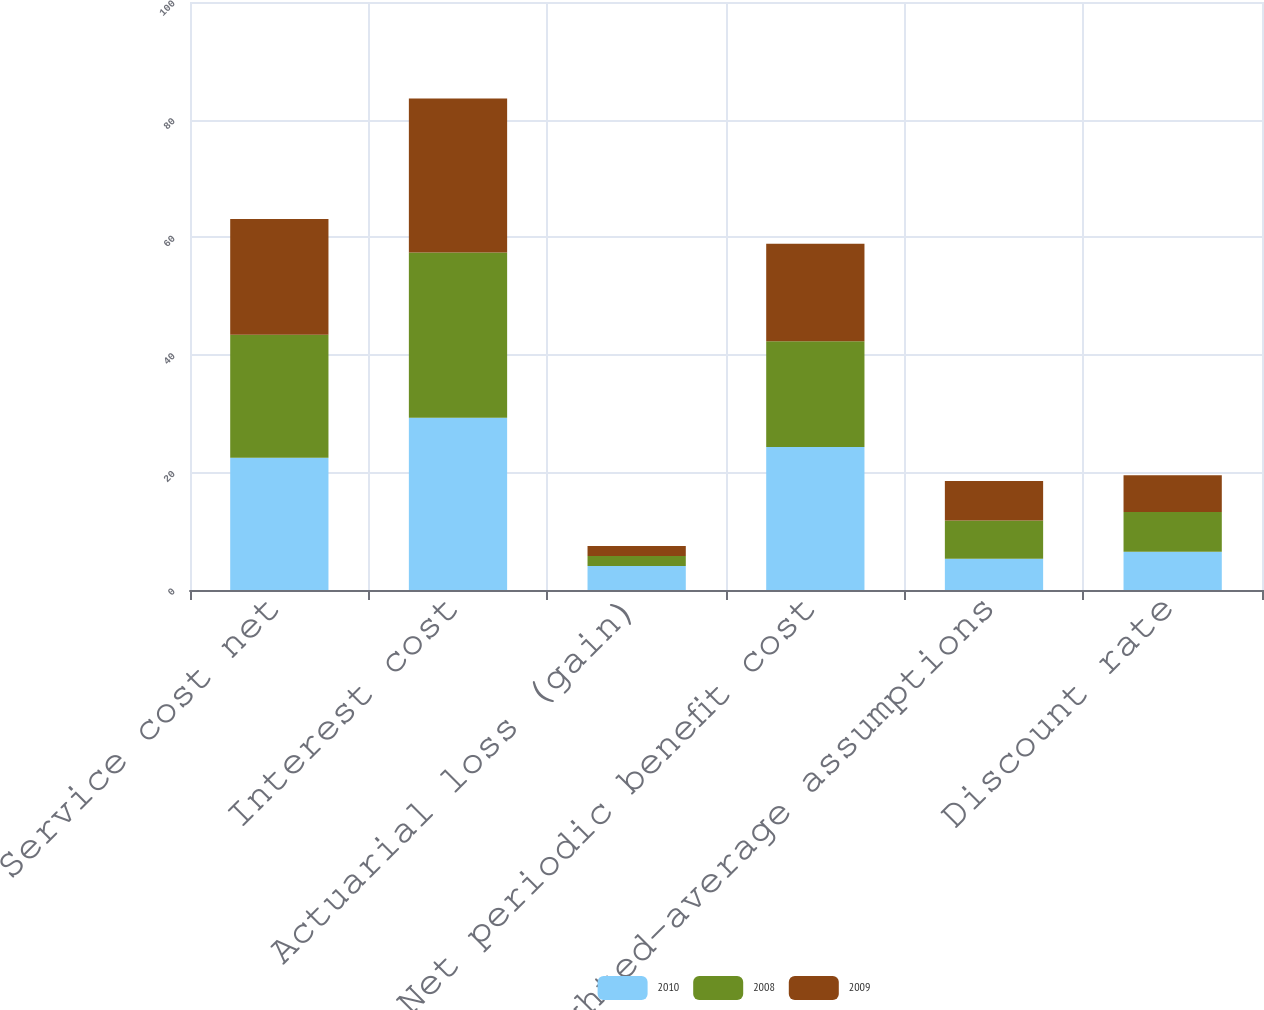<chart> <loc_0><loc_0><loc_500><loc_500><stacked_bar_chart><ecel><fcel>Service cost net<fcel>Interest cost<fcel>Actuarial loss (gain)<fcel>Net periodic benefit cost<fcel>Weighted-average assumptions<fcel>Discount rate<nl><fcel>2010<fcel>22.5<fcel>29.3<fcel>4.1<fcel>24.3<fcel>5.3<fcel>6.5<nl><fcel>2008<fcel>20.9<fcel>28.1<fcel>1.7<fcel>18<fcel>6.5<fcel>6.75<nl><fcel>2009<fcel>19.7<fcel>26.2<fcel>1.7<fcel>16.6<fcel>6.75<fcel>6.25<nl></chart> 